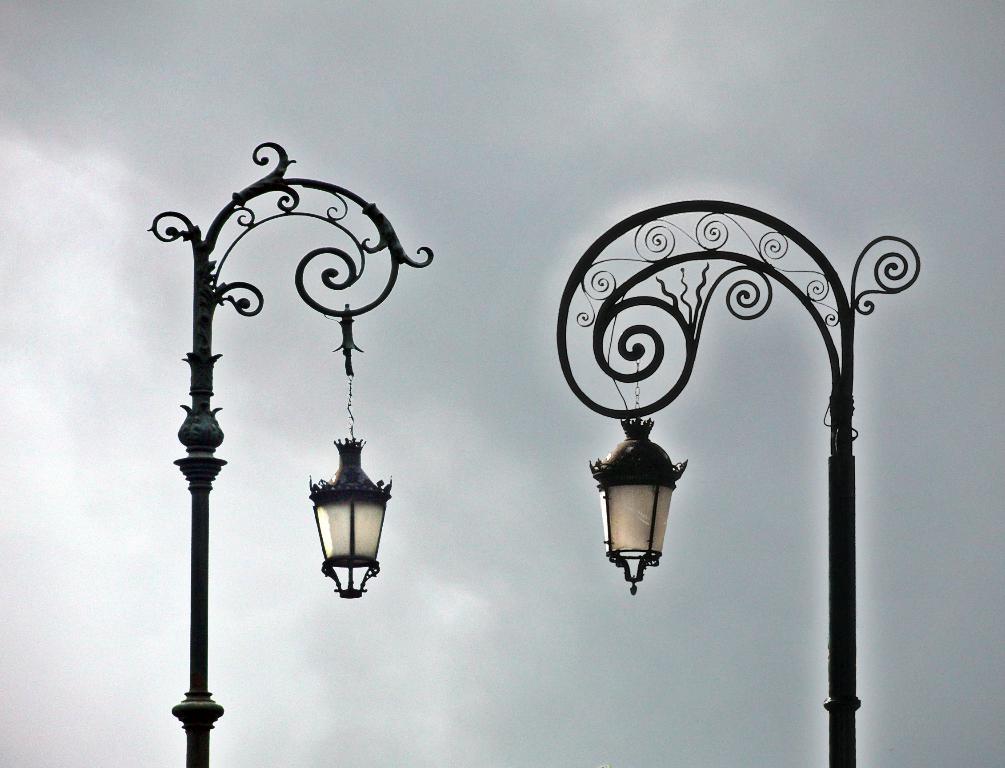How would you summarize this image in a sentence or two? In the image there are designer poles with lamps hanging to it. In the background there is a sky with clouds. 